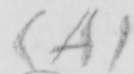Transcribe the text shown in this historical manuscript line. ( A ) 